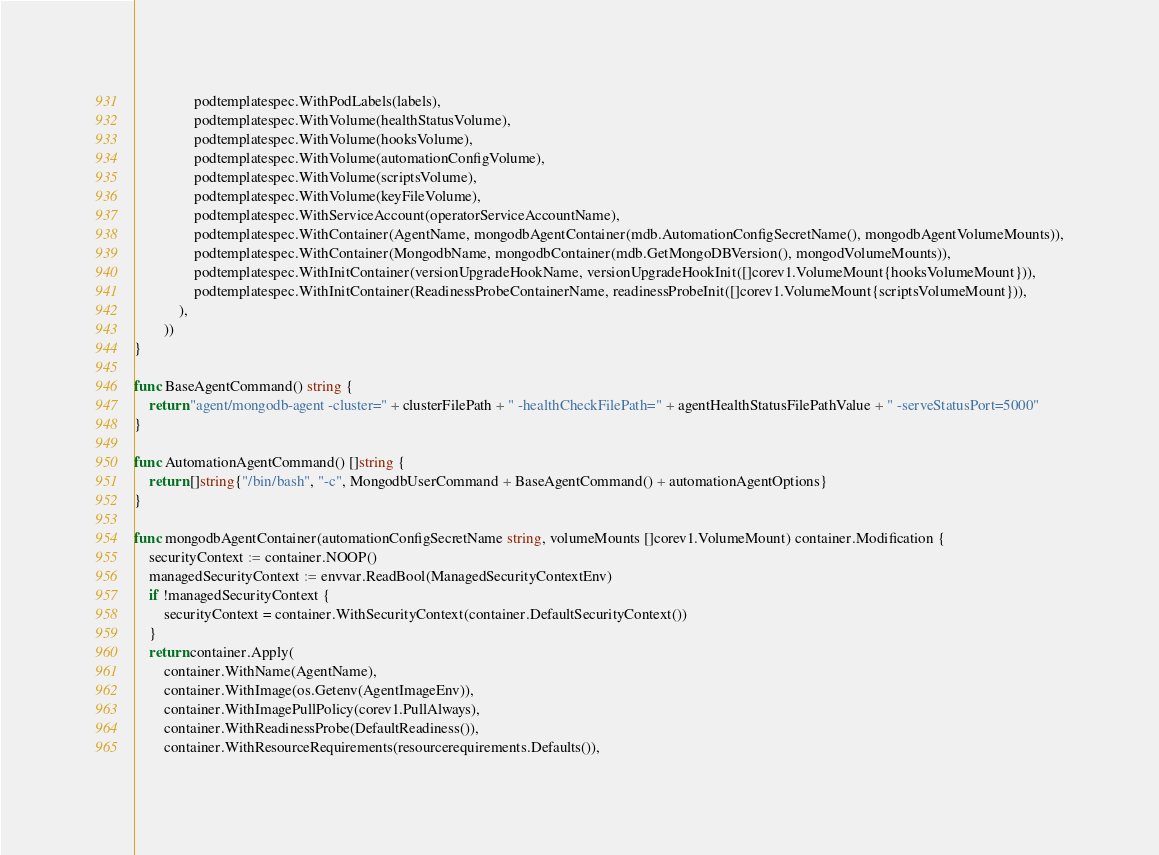<code> <loc_0><loc_0><loc_500><loc_500><_Go_>				podtemplatespec.WithPodLabels(labels),
				podtemplatespec.WithVolume(healthStatusVolume),
				podtemplatespec.WithVolume(hooksVolume),
				podtemplatespec.WithVolume(automationConfigVolume),
				podtemplatespec.WithVolume(scriptsVolume),
				podtemplatespec.WithVolume(keyFileVolume),
				podtemplatespec.WithServiceAccount(operatorServiceAccountName),
				podtemplatespec.WithContainer(AgentName, mongodbAgentContainer(mdb.AutomationConfigSecretName(), mongodbAgentVolumeMounts)),
				podtemplatespec.WithContainer(MongodbName, mongodbContainer(mdb.GetMongoDBVersion(), mongodVolumeMounts)),
				podtemplatespec.WithInitContainer(versionUpgradeHookName, versionUpgradeHookInit([]corev1.VolumeMount{hooksVolumeMount})),
				podtemplatespec.WithInitContainer(ReadinessProbeContainerName, readinessProbeInit([]corev1.VolumeMount{scriptsVolumeMount})),
			),
		))
}

func BaseAgentCommand() string {
	return "agent/mongodb-agent -cluster=" + clusterFilePath + " -healthCheckFilePath=" + agentHealthStatusFilePathValue + " -serveStatusPort=5000"
}

func AutomationAgentCommand() []string {
	return []string{"/bin/bash", "-c", MongodbUserCommand + BaseAgentCommand() + automationAgentOptions}
}

func mongodbAgentContainer(automationConfigSecretName string, volumeMounts []corev1.VolumeMount) container.Modification {
	securityContext := container.NOOP()
	managedSecurityContext := envvar.ReadBool(ManagedSecurityContextEnv)
	if !managedSecurityContext {
		securityContext = container.WithSecurityContext(container.DefaultSecurityContext())
	}
	return container.Apply(
		container.WithName(AgentName),
		container.WithImage(os.Getenv(AgentImageEnv)),
		container.WithImagePullPolicy(corev1.PullAlways),
		container.WithReadinessProbe(DefaultReadiness()),
		container.WithResourceRequirements(resourcerequirements.Defaults()),</code> 